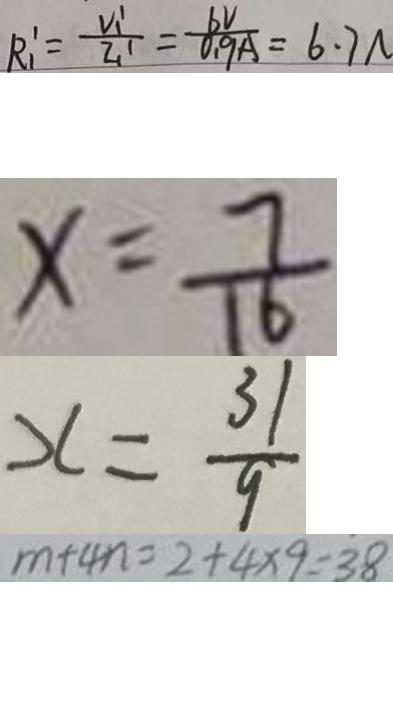<formula> <loc_0><loc_0><loc_500><loc_500>R _ { 1 } ^ { \prime } = \frac { V _ { 1 } ^ { \prime } } { I _ { 1 } ^ { \prime } } = \frac { 6 V } { 0 . 9 A } = 6 . 7 N 
 x = \frac { 7 } { 1 6 } 
 x = \frac { 3 1 } { 9 } 
 m + 4 n = 2 + 4 \times 9 = 3 8</formula> 